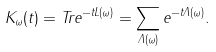<formula> <loc_0><loc_0><loc_500><loc_500>K _ { \omega } ( t ) = T r e ^ { - t L ( \omega ) } = \sum _ { \Lambda ( \omega ) } e ^ { - t \Lambda ( \omega ) } .</formula> 